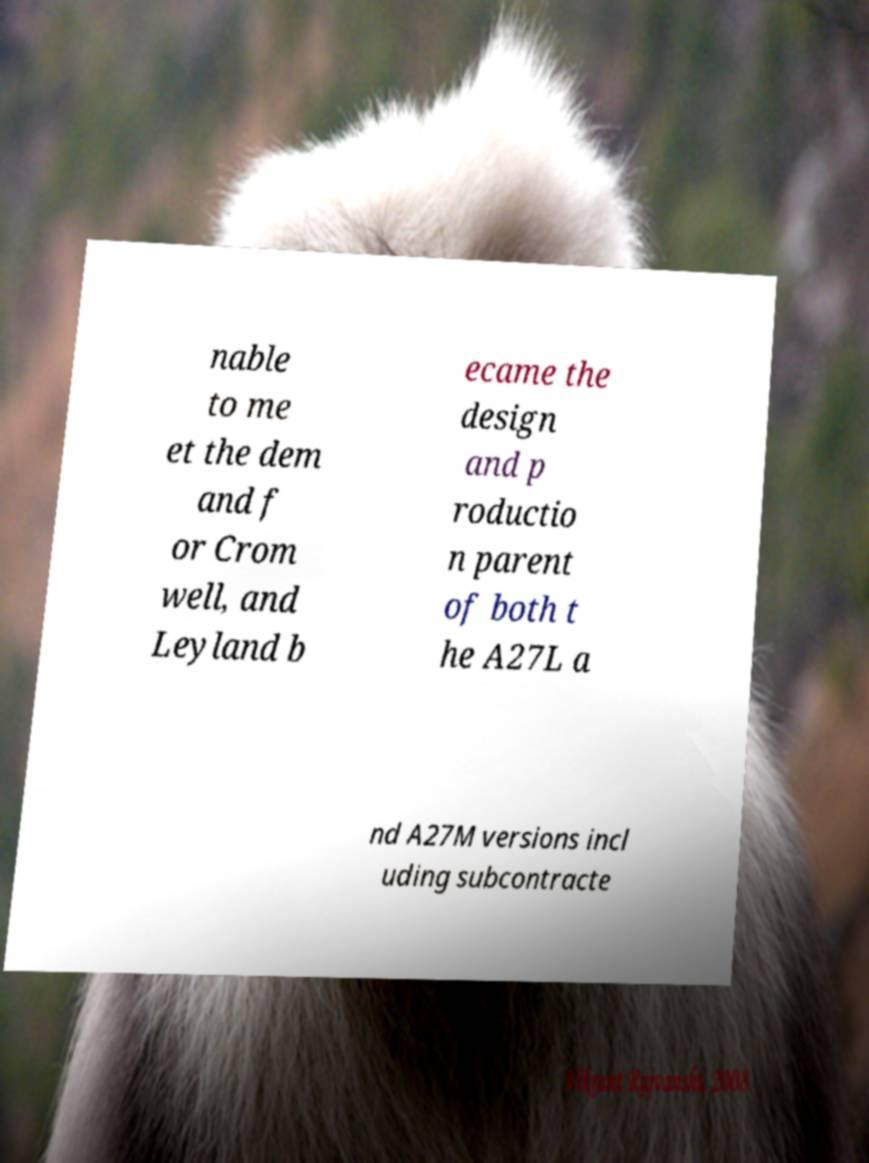There's text embedded in this image that I need extracted. Can you transcribe it verbatim? nable to me et the dem and f or Crom well, and Leyland b ecame the design and p roductio n parent of both t he A27L a nd A27M versions incl uding subcontracte 